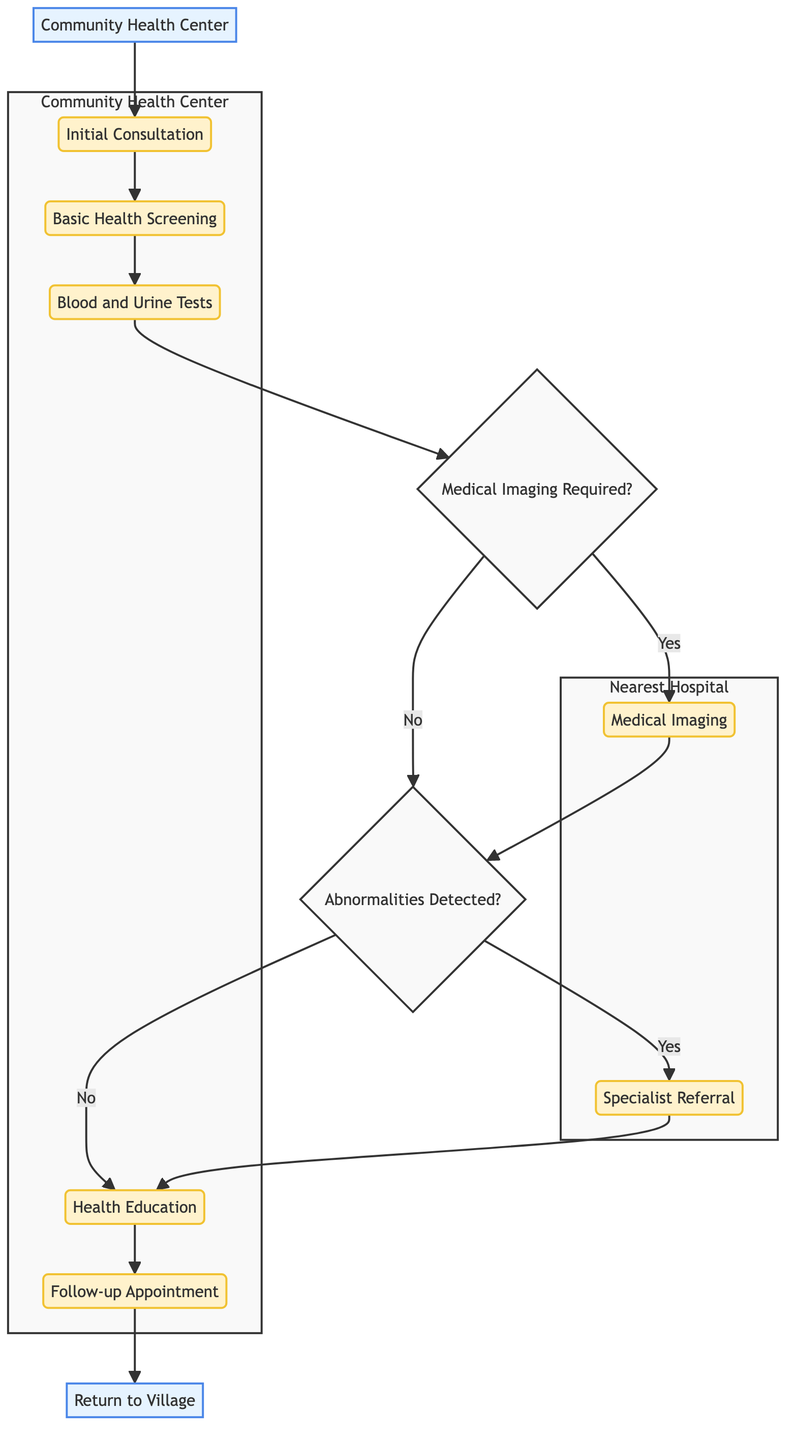What is the entry point of the clinical pathway? The entry point is labeled in the diagram as the starting location for the pathway, which is "Community Health Center."
Answer: Community Health Center How many steps are there in the clinical pathway? By counting the number of individual steps mentioned in the diagram's flow, we find there are a total of seven steps that make up the clinical pathway.
Answer: 7 Who is responsible for the basic health screening? The diagram specifies that the "Nurse" is the responsible party for carrying out the basic health screening step.
Answer: Nurse What is the last step before returning to the village? Reviewing the final connections in the diagram, the last step indicated before the exit point is the "Follow-up Appointment."
Answer: Follow-up Appointment Is medical imaging required for every patient? The diagram shows a decision point indicating that medical imaging is only required if certain conditions are met, rather than for every patient. This demonstrates contingency in the clinical pathway.
Answer: No What location is responsible for conducting medical imaging? Following the flow, the diagram indicates that "Nearest Hospital" is the location designated for conducting medical imaging procedures.
Answer: Nearest Hospital If abnormalities are detected, what is the next step? According to the decision flow, if abnormalities are detected after screenings, the next step would be a "Specialist Referral."
Answer: Specialist Referral What type of health services are provided during health education? Based on the description in the diagram, health education focuses on providing information regarding maintaining a healthy lifestyle and managing chronic conditions.
Answer: Healthy lifestyle information Who performs the blood and urine tests? The diagram explicitly states that the "Lab Technician" is the responsible party for collecting blood and urine samples needed for testing.
Answer: Lab Technician 